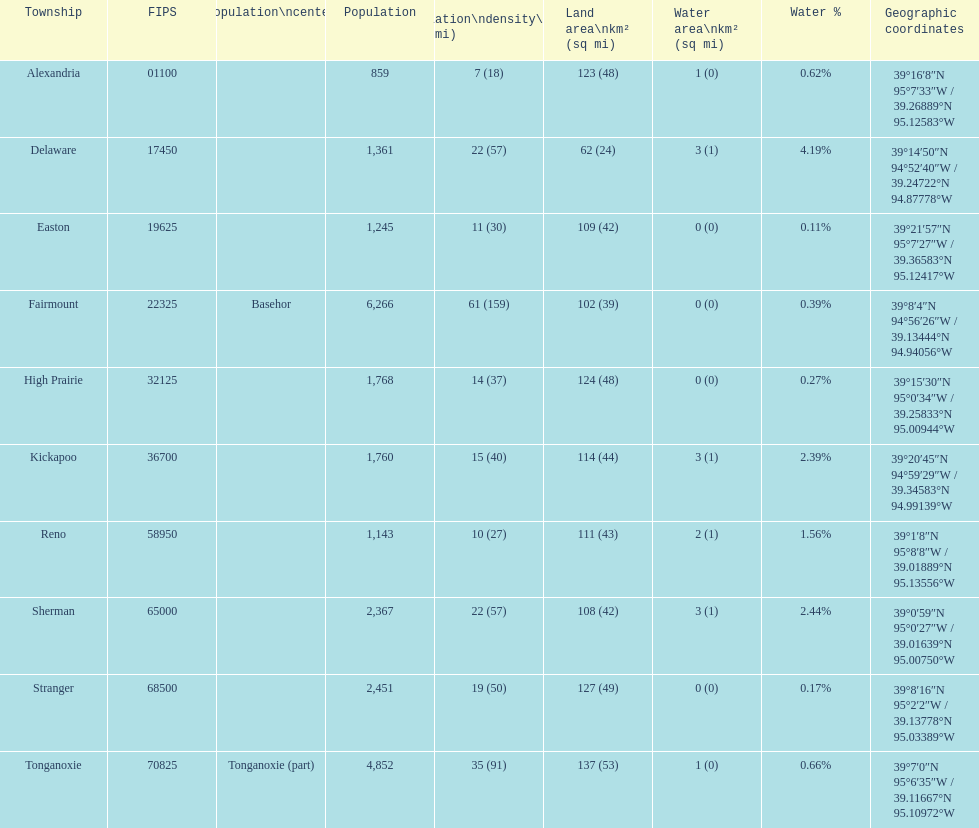How many townships are in leavenworth county? 10. 